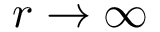<formula> <loc_0><loc_0><loc_500><loc_500>r \rightarrow \infty</formula> 